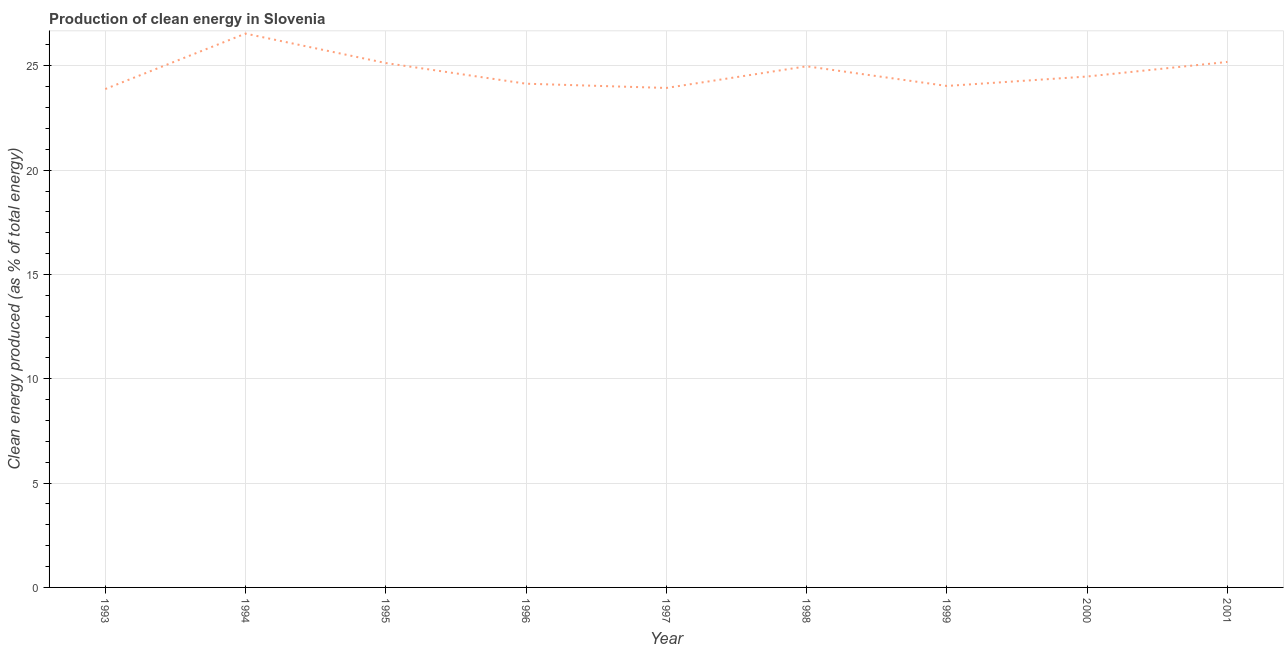What is the production of clean energy in 1994?
Make the answer very short. 26.55. Across all years, what is the maximum production of clean energy?
Your answer should be very brief. 26.55. Across all years, what is the minimum production of clean energy?
Your answer should be very brief. 23.89. In which year was the production of clean energy maximum?
Provide a succinct answer. 1994. In which year was the production of clean energy minimum?
Your response must be concise. 1993. What is the sum of the production of clean energy?
Offer a very short reply. 222.34. What is the difference between the production of clean energy in 1998 and 2000?
Make the answer very short. 0.49. What is the average production of clean energy per year?
Offer a terse response. 24.7. What is the median production of clean energy?
Give a very brief answer. 24.49. Do a majority of the years between 2001 and 1995 (inclusive) have production of clean energy greater than 6 %?
Keep it short and to the point. Yes. What is the ratio of the production of clean energy in 1993 to that in 1996?
Keep it short and to the point. 0.99. What is the difference between the highest and the second highest production of clean energy?
Give a very brief answer. 1.36. Is the sum of the production of clean energy in 1995 and 1999 greater than the maximum production of clean energy across all years?
Give a very brief answer. Yes. What is the difference between the highest and the lowest production of clean energy?
Give a very brief answer. 2.66. Does the production of clean energy monotonically increase over the years?
Your answer should be very brief. No. How many years are there in the graph?
Offer a very short reply. 9. Are the values on the major ticks of Y-axis written in scientific E-notation?
Offer a very short reply. No. What is the title of the graph?
Provide a short and direct response. Production of clean energy in Slovenia. What is the label or title of the X-axis?
Provide a succinct answer. Year. What is the label or title of the Y-axis?
Provide a succinct answer. Clean energy produced (as % of total energy). What is the Clean energy produced (as % of total energy) of 1993?
Your response must be concise. 23.89. What is the Clean energy produced (as % of total energy) in 1994?
Make the answer very short. 26.55. What is the Clean energy produced (as % of total energy) of 1995?
Provide a succinct answer. 25.13. What is the Clean energy produced (as % of total energy) of 1996?
Offer a terse response. 24.14. What is the Clean energy produced (as % of total energy) of 1997?
Offer a very short reply. 23.94. What is the Clean energy produced (as % of total energy) in 1998?
Make the answer very short. 24.98. What is the Clean energy produced (as % of total energy) of 1999?
Provide a short and direct response. 24.04. What is the Clean energy produced (as % of total energy) in 2000?
Keep it short and to the point. 24.49. What is the Clean energy produced (as % of total energy) of 2001?
Offer a terse response. 25.19. What is the difference between the Clean energy produced (as % of total energy) in 1993 and 1994?
Give a very brief answer. -2.66. What is the difference between the Clean energy produced (as % of total energy) in 1993 and 1995?
Your answer should be compact. -1.25. What is the difference between the Clean energy produced (as % of total energy) in 1993 and 1996?
Offer a terse response. -0.26. What is the difference between the Clean energy produced (as % of total energy) in 1993 and 1997?
Your answer should be compact. -0.05. What is the difference between the Clean energy produced (as % of total energy) in 1993 and 1998?
Your answer should be compact. -1.09. What is the difference between the Clean energy produced (as % of total energy) in 1993 and 1999?
Give a very brief answer. -0.15. What is the difference between the Clean energy produced (as % of total energy) in 1993 and 2000?
Your response must be concise. -0.6. What is the difference between the Clean energy produced (as % of total energy) in 1993 and 2001?
Your answer should be compact. -1.3. What is the difference between the Clean energy produced (as % of total energy) in 1994 and 1995?
Make the answer very short. 1.41. What is the difference between the Clean energy produced (as % of total energy) in 1994 and 1996?
Your response must be concise. 2.4. What is the difference between the Clean energy produced (as % of total energy) in 1994 and 1997?
Your response must be concise. 2.61. What is the difference between the Clean energy produced (as % of total energy) in 1994 and 1998?
Your response must be concise. 1.57. What is the difference between the Clean energy produced (as % of total energy) in 1994 and 1999?
Your answer should be compact. 2.51. What is the difference between the Clean energy produced (as % of total energy) in 1994 and 2000?
Offer a terse response. 2.06. What is the difference between the Clean energy produced (as % of total energy) in 1994 and 2001?
Offer a very short reply. 1.36. What is the difference between the Clean energy produced (as % of total energy) in 1995 and 1996?
Ensure brevity in your answer.  0.99. What is the difference between the Clean energy produced (as % of total energy) in 1995 and 1997?
Give a very brief answer. 1.19. What is the difference between the Clean energy produced (as % of total energy) in 1995 and 1998?
Offer a very short reply. 0.16. What is the difference between the Clean energy produced (as % of total energy) in 1995 and 1999?
Provide a short and direct response. 1.1. What is the difference between the Clean energy produced (as % of total energy) in 1995 and 2000?
Provide a short and direct response. 0.65. What is the difference between the Clean energy produced (as % of total energy) in 1995 and 2001?
Give a very brief answer. -0.05. What is the difference between the Clean energy produced (as % of total energy) in 1996 and 1997?
Provide a short and direct response. 0.2. What is the difference between the Clean energy produced (as % of total energy) in 1996 and 1998?
Your response must be concise. -0.83. What is the difference between the Clean energy produced (as % of total energy) in 1996 and 1999?
Provide a succinct answer. 0.11. What is the difference between the Clean energy produced (as % of total energy) in 1996 and 2000?
Give a very brief answer. -0.34. What is the difference between the Clean energy produced (as % of total energy) in 1996 and 2001?
Provide a short and direct response. -1.04. What is the difference between the Clean energy produced (as % of total energy) in 1997 and 1998?
Provide a succinct answer. -1.04. What is the difference between the Clean energy produced (as % of total energy) in 1997 and 1999?
Your response must be concise. -0.1. What is the difference between the Clean energy produced (as % of total energy) in 1997 and 2000?
Give a very brief answer. -0.55. What is the difference between the Clean energy produced (as % of total energy) in 1997 and 2001?
Offer a very short reply. -1.25. What is the difference between the Clean energy produced (as % of total energy) in 1998 and 1999?
Keep it short and to the point. 0.94. What is the difference between the Clean energy produced (as % of total energy) in 1998 and 2000?
Provide a short and direct response. 0.49. What is the difference between the Clean energy produced (as % of total energy) in 1998 and 2001?
Your answer should be very brief. -0.21. What is the difference between the Clean energy produced (as % of total energy) in 1999 and 2000?
Give a very brief answer. -0.45. What is the difference between the Clean energy produced (as % of total energy) in 1999 and 2001?
Offer a terse response. -1.15. What is the difference between the Clean energy produced (as % of total energy) in 2000 and 2001?
Make the answer very short. -0.7. What is the ratio of the Clean energy produced (as % of total energy) in 1993 to that in 1995?
Provide a short and direct response. 0.95. What is the ratio of the Clean energy produced (as % of total energy) in 1993 to that in 1996?
Offer a terse response. 0.99. What is the ratio of the Clean energy produced (as % of total energy) in 1993 to that in 1997?
Keep it short and to the point. 1. What is the ratio of the Clean energy produced (as % of total energy) in 1993 to that in 1998?
Keep it short and to the point. 0.96. What is the ratio of the Clean energy produced (as % of total energy) in 1993 to that in 1999?
Your response must be concise. 0.99. What is the ratio of the Clean energy produced (as % of total energy) in 1993 to that in 2001?
Provide a succinct answer. 0.95. What is the ratio of the Clean energy produced (as % of total energy) in 1994 to that in 1995?
Provide a short and direct response. 1.06. What is the ratio of the Clean energy produced (as % of total energy) in 1994 to that in 1996?
Ensure brevity in your answer.  1.1. What is the ratio of the Clean energy produced (as % of total energy) in 1994 to that in 1997?
Your answer should be very brief. 1.11. What is the ratio of the Clean energy produced (as % of total energy) in 1994 to that in 1998?
Your answer should be compact. 1.06. What is the ratio of the Clean energy produced (as % of total energy) in 1994 to that in 1999?
Offer a very short reply. 1.1. What is the ratio of the Clean energy produced (as % of total energy) in 1994 to that in 2000?
Provide a short and direct response. 1.08. What is the ratio of the Clean energy produced (as % of total energy) in 1994 to that in 2001?
Keep it short and to the point. 1.05. What is the ratio of the Clean energy produced (as % of total energy) in 1995 to that in 1996?
Your response must be concise. 1.04. What is the ratio of the Clean energy produced (as % of total energy) in 1995 to that in 1999?
Offer a very short reply. 1.05. What is the ratio of the Clean energy produced (as % of total energy) in 1995 to that in 2000?
Offer a terse response. 1.03. What is the ratio of the Clean energy produced (as % of total energy) in 1995 to that in 2001?
Your response must be concise. 1. What is the ratio of the Clean energy produced (as % of total energy) in 1996 to that in 1998?
Offer a terse response. 0.97. What is the ratio of the Clean energy produced (as % of total energy) in 1997 to that in 1998?
Make the answer very short. 0.96. What is the ratio of the Clean energy produced (as % of total energy) in 1998 to that in 1999?
Give a very brief answer. 1.04. What is the ratio of the Clean energy produced (as % of total energy) in 1999 to that in 2000?
Your answer should be compact. 0.98. What is the ratio of the Clean energy produced (as % of total energy) in 1999 to that in 2001?
Make the answer very short. 0.95. What is the ratio of the Clean energy produced (as % of total energy) in 2000 to that in 2001?
Provide a succinct answer. 0.97. 